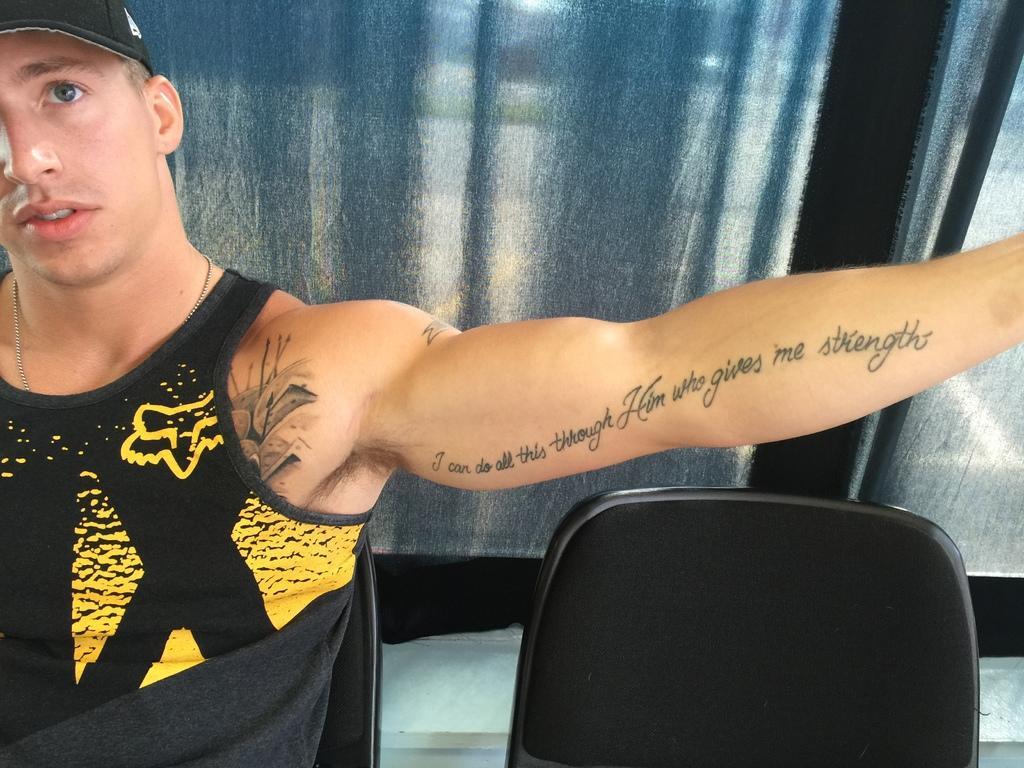How would you summarize this image in a sentence or two? In this image we can see this person wearing black T-shirt, cap and chain is sitting on the chair and is having the tattoo on his chest and on his hand. Here we can see the chair and in the background, we can see the curtains. 